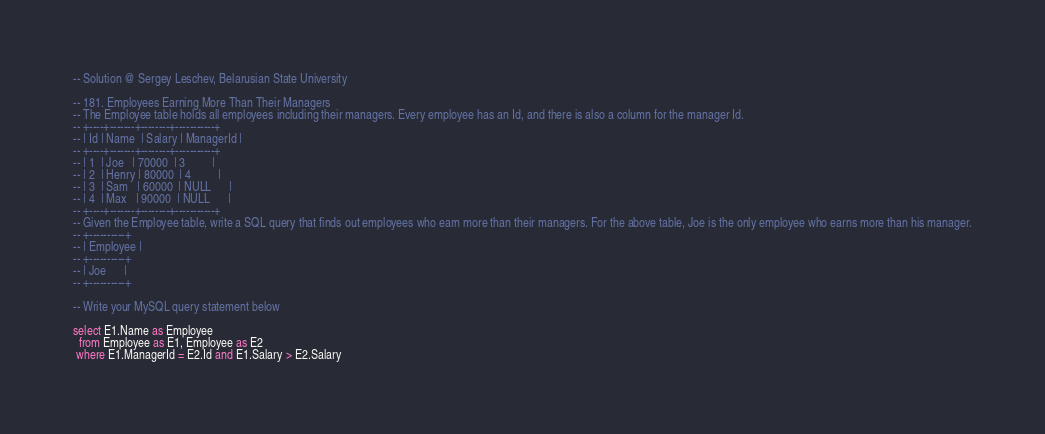Convert code to text. <code><loc_0><loc_0><loc_500><loc_500><_SQL_>-- Solution @ Sergey Leschev, Belarusian State University

-- 181. Employees Earning More Than Their Managers
-- The Employee table holds all employees including their managers. Every employee has an Id, and there is also a column for the manager Id.
-- +----+-------+--------+-----------+
-- | Id | Name  | Salary | ManagerId |
-- +----+-------+--------+-----------+
-- | 1  | Joe   | 70000  | 3         |
-- | 2  | Henry | 80000  | 4         |
-- | 3  | Sam   | 60000  | NULL      |
-- | 4  | Max   | 90000  | NULL      |
-- +----+-------+--------+-----------+
-- Given the Employee table, write a SQL query that finds out employees who earn more than their managers. For the above table, Joe is the only employee who earns more than his manager.
-- +----------+
-- | Employee |
-- +----------+
-- | Joe      |
-- +----------+

-- Write your MySQL query statement below

select E1.Name as Employee
  from Employee as E1, Employee as E2 
 where E1.ManagerId = E2.Id and E1.Salary > E2.Salary</code> 